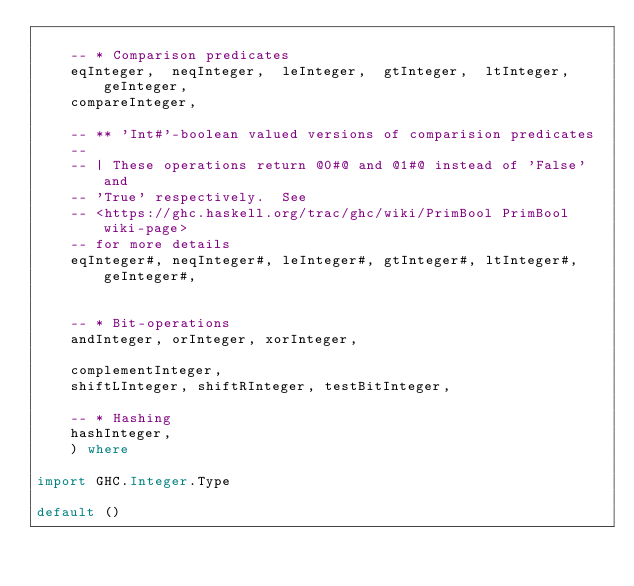Convert code to text. <code><loc_0><loc_0><loc_500><loc_500><_Haskell_>
    -- * Comparison predicates
    eqInteger,  neqInteger,  leInteger,  gtInteger,  ltInteger,  geInteger,
    compareInteger,

    -- ** 'Int#'-boolean valued versions of comparision predicates
    --
    -- | These operations return @0#@ and @1#@ instead of 'False' and
    -- 'True' respectively.  See
    -- <https://ghc.haskell.org/trac/ghc/wiki/PrimBool PrimBool wiki-page>
    -- for more details
    eqInteger#, neqInteger#, leInteger#, gtInteger#, ltInteger#, geInteger#,


    -- * Bit-operations
    andInteger, orInteger, xorInteger,

    complementInteger,
    shiftLInteger, shiftRInteger, testBitInteger,

    -- * Hashing
    hashInteger,
    ) where

import GHC.Integer.Type

default ()
</code> 